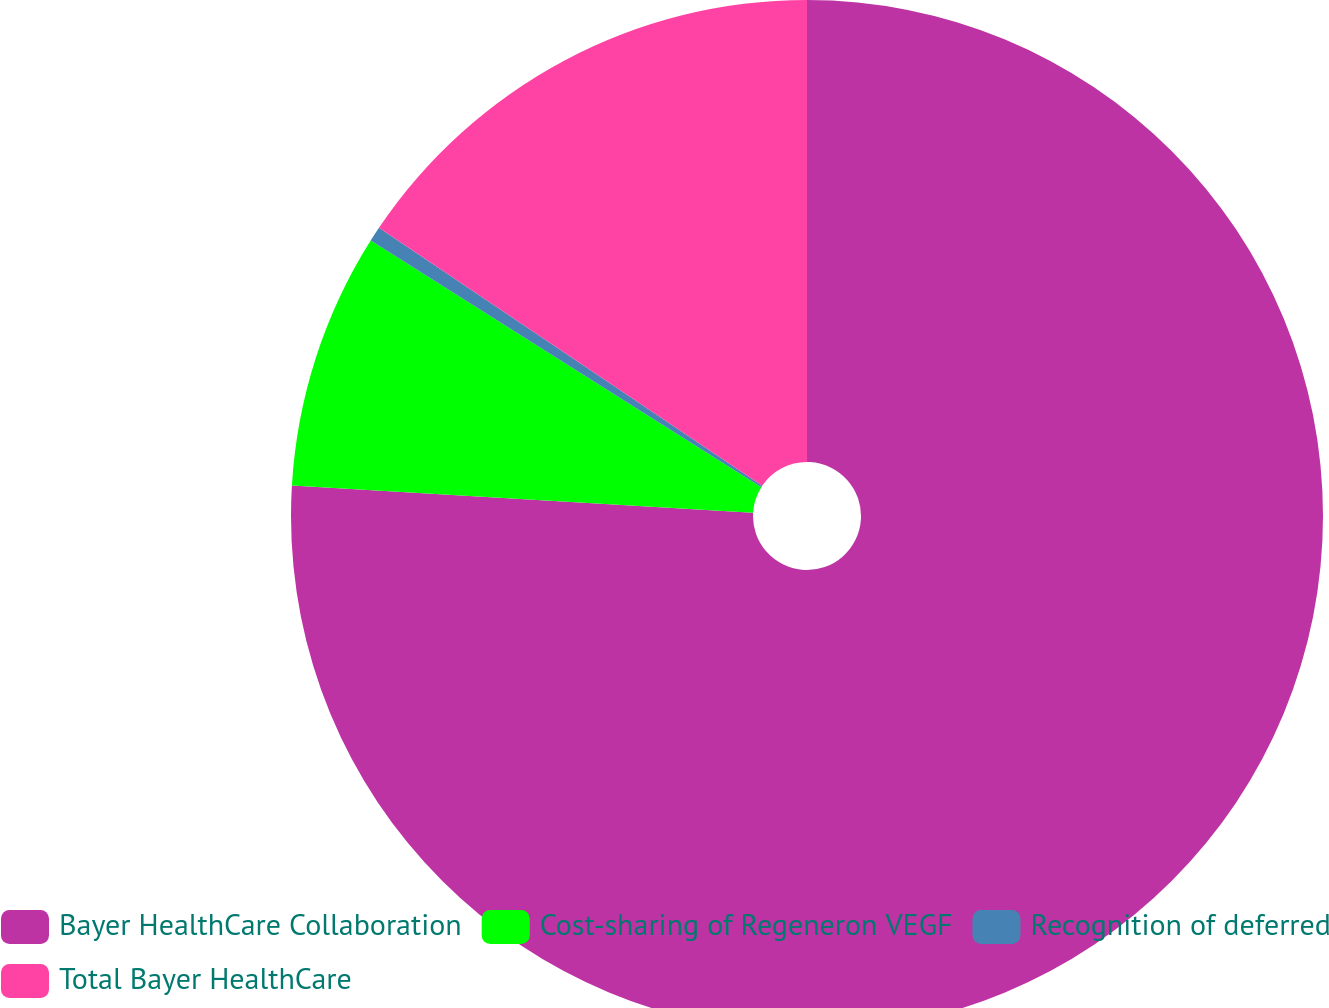Convert chart. <chart><loc_0><loc_0><loc_500><loc_500><pie_chart><fcel>Bayer HealthCare Collaboration<fcel>Cost-sharing of Regeneron VEGF<fcel>Recognition of deferred<fcel>Total Bayer HealthCare<nl><fcel>75.95%<fcel>8.02%<fcel>0.47%<fcel>15.57%<nl></chart> 